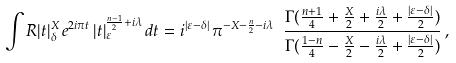Convert formula to latex. <formula><loc_0><loc_0><loc_500><loc_500>\int R | t | _ { \delta } ^ { X } \, e ^ { 2 i \pi t } \, | t | _ { \varepsilon } ^ { \frac { n - 1 } { 2 } + i \lambda } \, d t = i ^ { | \varepsilon - \delta | } \, \pi ^ { - X - \frac { n } { 2 } - i \lambda } \ \frac { \Gamma ( \frac { n + 1 } { 4 } + \frac { X } { 2 } + \frac { i \lambda } { 2 } + \frac { | \varepsilon - \delta | } { 2 } ) } { \Gamma ( \frac { 1 - n } { 4 } - \frac { X } { 2 } - \frac { i \lambda } { 2 } + \frac { | \varepsilon - \delta | } { 2 } ) } \, ,</formula> 